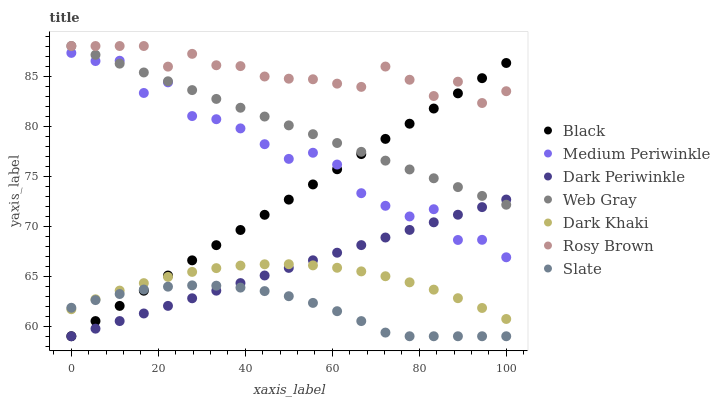Does Slate have the minimum area under the curve?
Answer yes or no. Yes. Does Rosy Brown have the maximum area under the curve?
Answer yes or no. Yes. Does Rosy Brown have the minimum area under the curve?
Answer yes or no. No. Does Slate have the maximum area under the curve?
Answer yes or no. No. Is Web Gray the smoothest?
Answer yes or no. Yes. Is Medium Periwinkle the roughest?
Answer yes or no. Yes. Is Slate the smoothest?
Answer yes or no. No. Is Slate the roughest?
Answer yes or no. No. Does Slate have the lowest value?
Answer yes or no. Yes. Does Rosy Brown have the lowest value?
Answer yes or no. No. Does Rosy Brown have the highest value?
Answer yes or no. Yes. Does Slate have the highest value?
Answer yes or no. No. Is Dark Khaki less than Rosy Brown?
Answer yes or no. Yes. Is Rosy Brown greater than Dark Periwinkle?
Answer yes or no. Yes. Does Rosy Brown intersect Black?
Answer yes or no. Yes. Is Rosy Brown less than Black?
Answer yes or no. No. Is Rosy Brown greater than Black?
Answer yes or no. No. Does Dark Khaki intersect Rosy Brown?
Answer yes or no. No. 